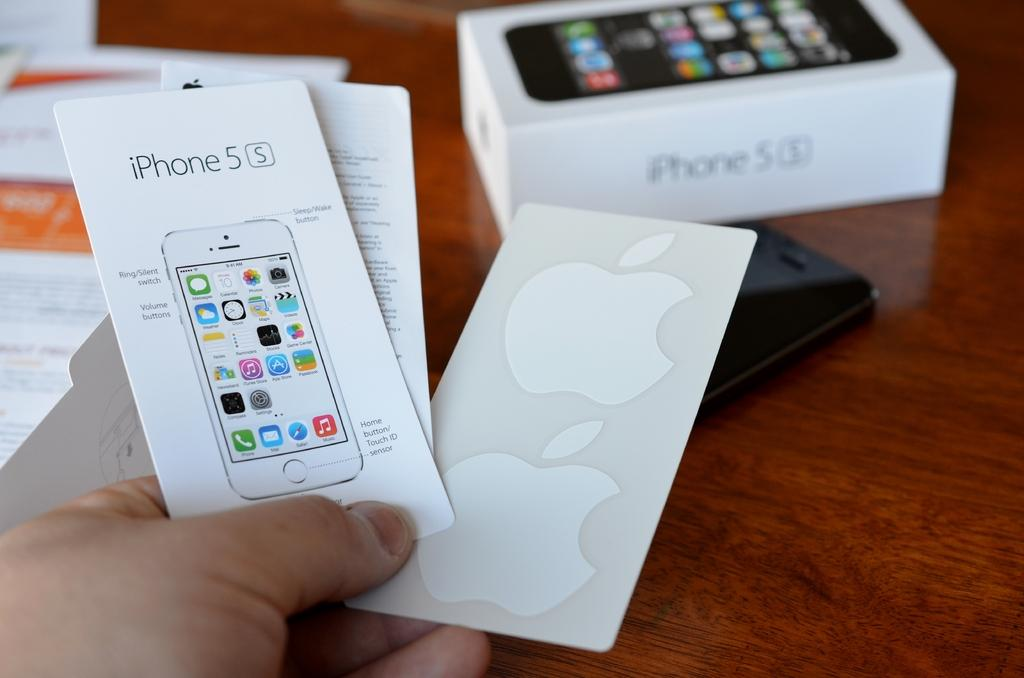<image>
Provide a brief description of the given image. A hand holding an iphone 5s booklet and Apple stickers with the iphone 5s box in the background. 